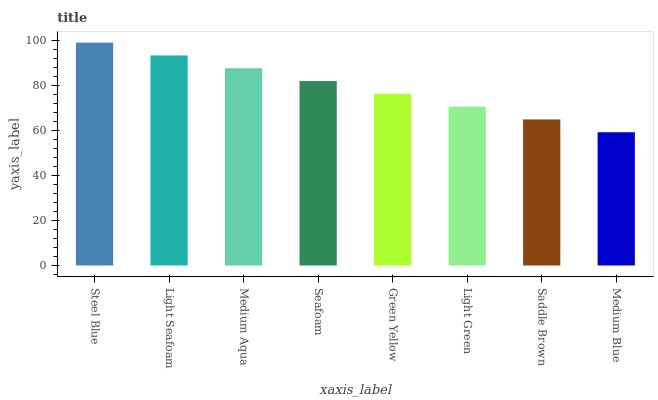Is Light Seafoam the minimum?
Answer yes or no. No. Is Light Seafoam the maximum?
Answer yes or no. No. Is Steel Blue greater than Light Seafoam?
Answer yes or no. Yes. Is Light Seafoam less than Steel Blue?
Answer yes or no. Yes. Is Light Seafoam greater than Steel Blue?
Answer yes or no. No. Is Steel Blue less than Light Seafoam?
Answer yes or no. No. Is Seafoam the high median?
Answer yes or no. Yes. Is Green Yellow the low median?
Answer yes or no. Yes. Is Medium Blue the high median?
Answer yes or no. No. Is Medium Aqua the low median?
Answer yes or no. No. 